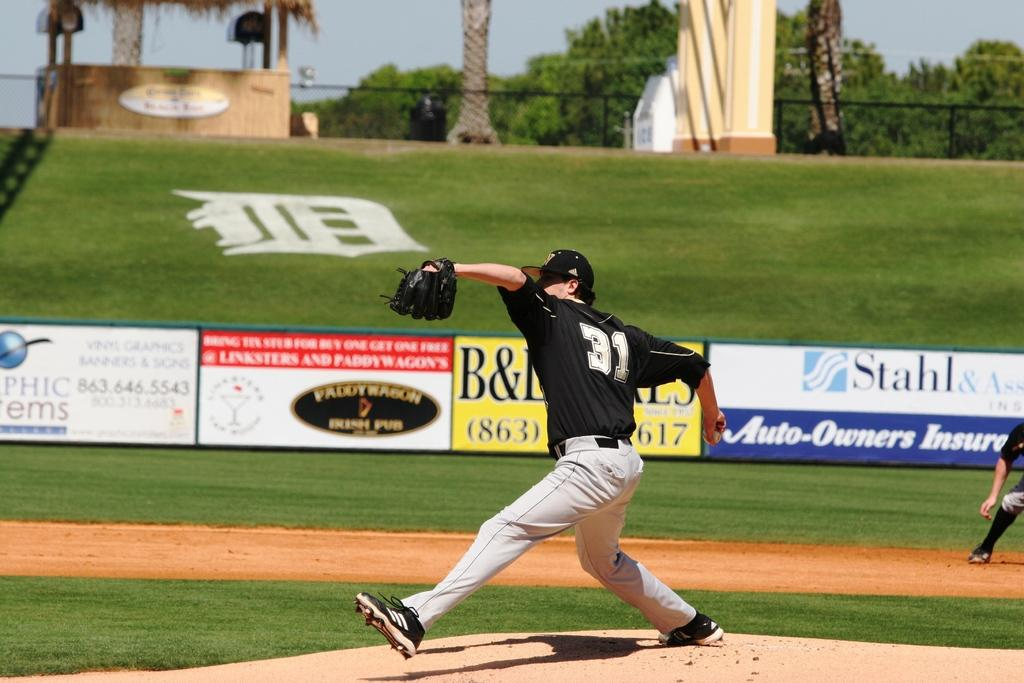<image>
Give a short and clear explanation of the subsequent image. a player throwing a ball with the number 31 on 